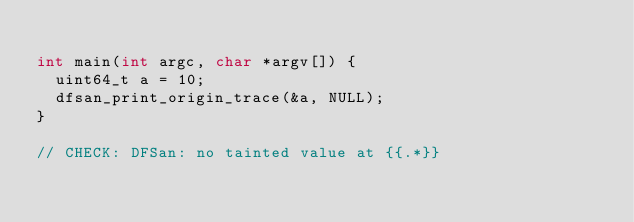<code> <loc_0><loc_0><loc_500><loc_500><_C_>
int main(int argc, char *argv[]) {
  uint64_t a = 10;
  dfsan_print_origin_trace(&a, NULL);
}

// CHECK: DFSan: no tainted value at {{.*}}
</code> 